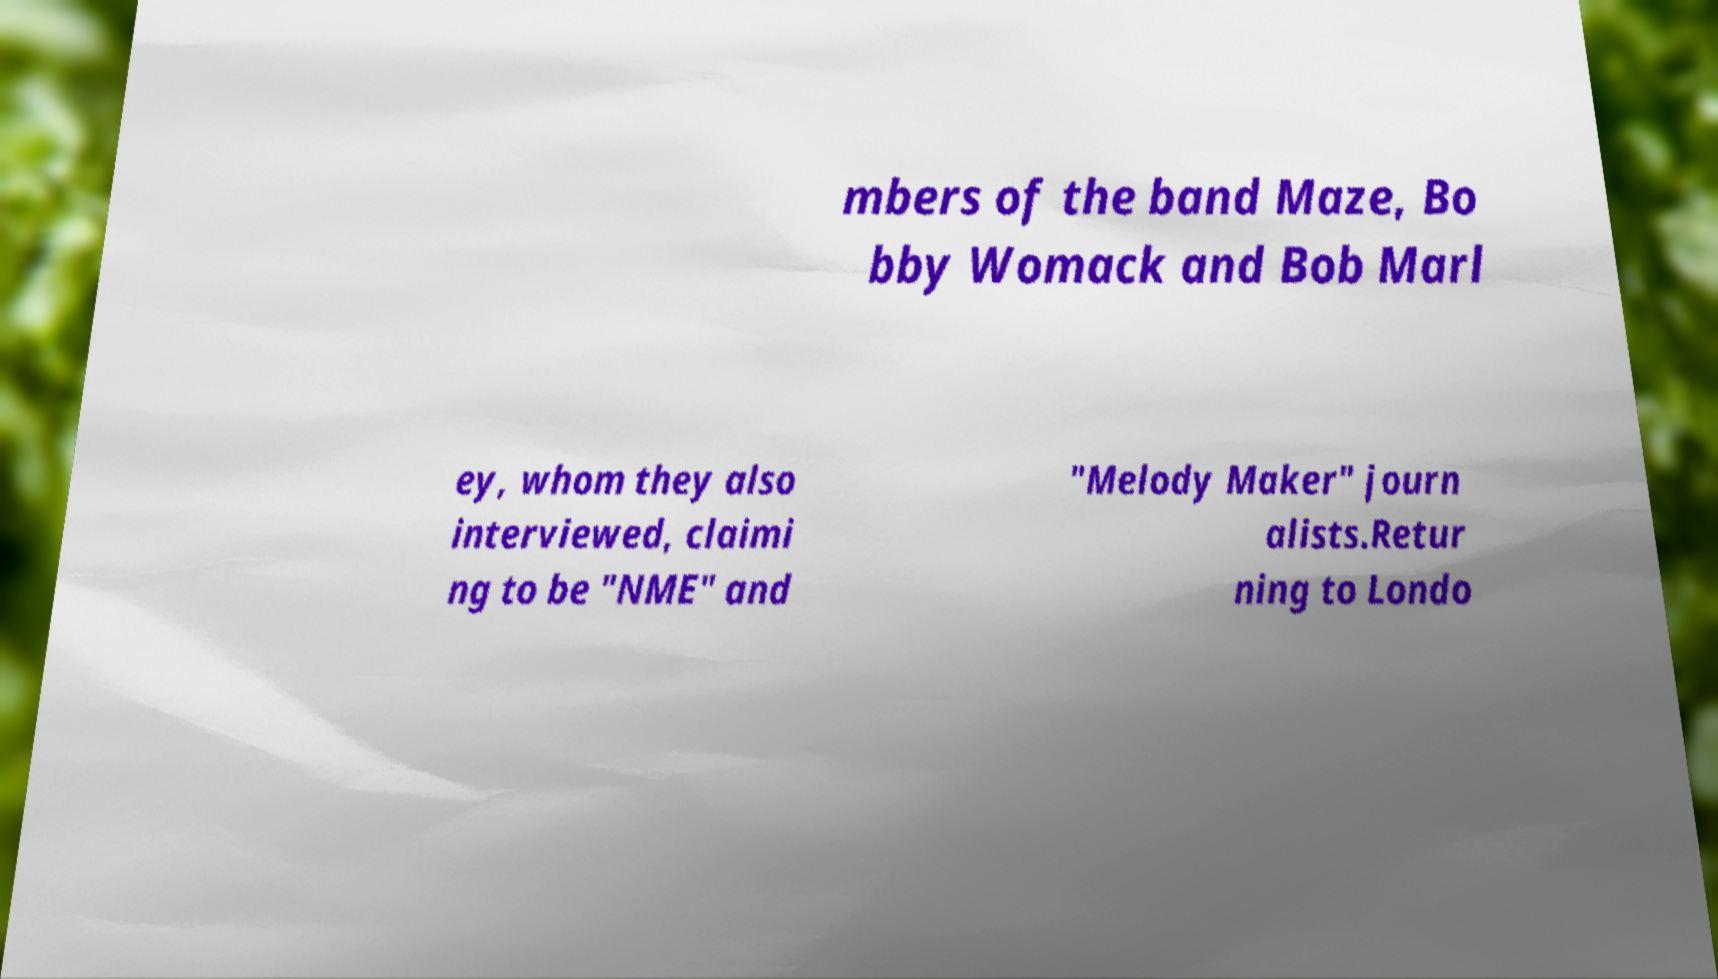What messages or text are displayed in this image? I need them in a readable, typed format. mbers of the band Maze, Bo bby Womack and Bob Marl ey, whom they also interviewed, claimi ng to be "NME" and "Melody Maker" journ alists.Retur ning to Londo 